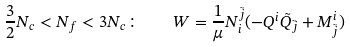Convert formula to latex. <formula><loc_0><loc_0><loc_500><loc_500>\frac { 3 } { 2 } N _ { c } < N _ { f } < 3 N _ { c } \colon \quad W = \frac { 1 } { \mu } N _ { i } ^ { \tilde { j } } ( - Q ^ { i } \tilde { Q } _ { \tilde { j } } + M ^ { i } _ { \tilde { j } } )</formula> 